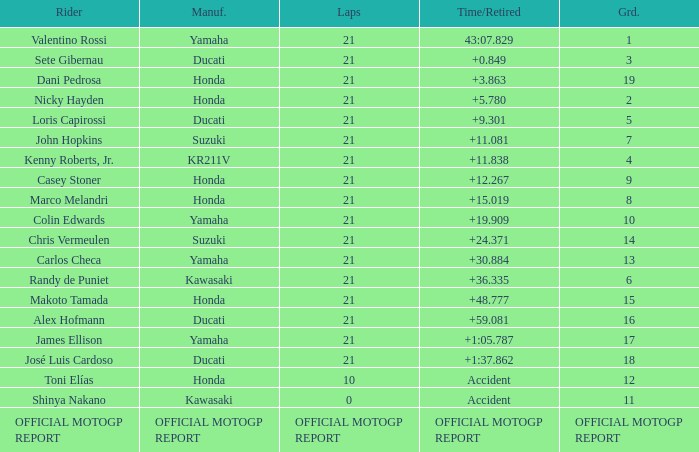Which rider had a time/retired od +19.909? Colin Edwards. 